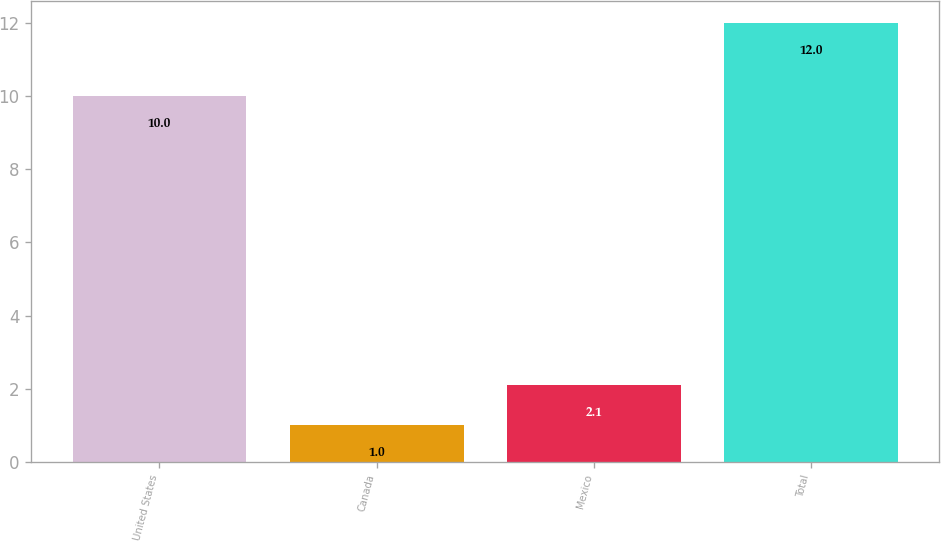Convert chart. <chart><loc_0><loc_0><loc_500><loc_500><bar_chart><fcel>United States<fcel>Canada<fcel>Mexico<fcel>Total<nl><fcel>10<fcel>1<fcel>2.1<fcel>12<nl></chart> 